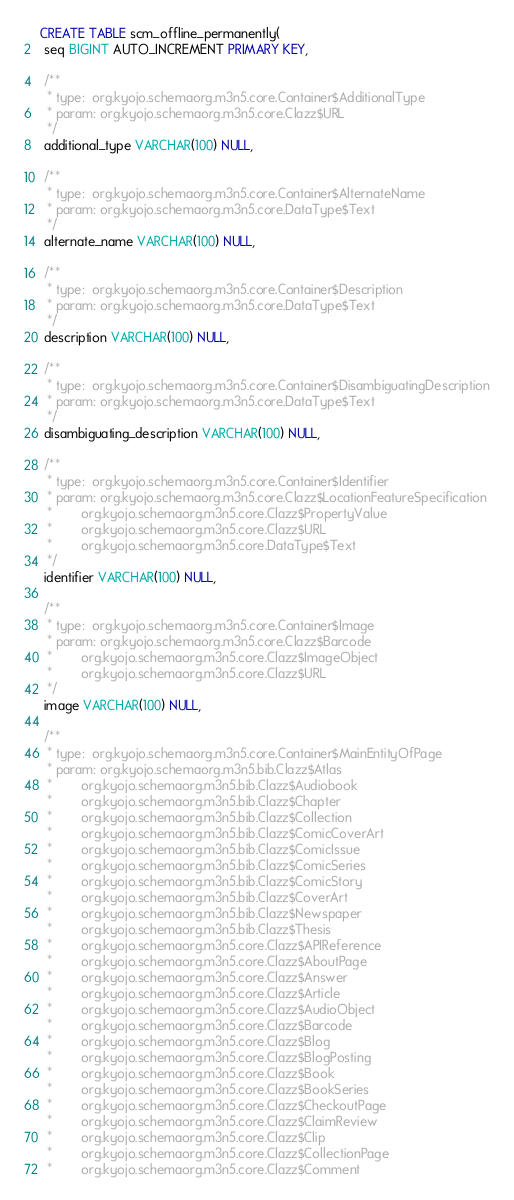Convert code to text. <code><loc_0><loc_0><loc_500><loc_500><_SQL_>CREATE TABLE scm_offline_permanently(
 seq BIGINT AUTO_INCREMENT PRIMARY KEY,

 /**
  * type:  org.kyojo.schemaorg.m3n5.core.Container$AdditionalType
  * param: org.kyojo.schemaorg.m3n5.core.Clazz$URL
  */
 additional_type VARCHAR(100) NULL,

 /**
  * type:  org.kyojo.schemaorg.m3n5.core.Container$AlternateName
  * param: org.kyojo.schemaorg.m3n5.core.DataType$Text
  */
 alternate_name VARCHAR(100) NULL,

 /**
  * type:  org.kyojo.schemaorg.m3n5.core.Container$Description
  * param: org.kyojo.schemaorg.m3n5.core.DataType$Text
  */
 description VARCHAR(100) NULL,

 /**
  * type:  org.kyojo.schemaorg.m3n5.core.Container$DisambiguatingDescription
  * param: org.kyojo.schemaorg.m3n5.core.DataType$Text
  */
 disambiguating_description VARCHAR(100) NULL,

 /**
  * type:  org.kyojo.schemaorg.m3n5.core.Container$Identifier
  * param: org.kyojo.schemaorg.m3n5.core.Clazz$LocationFeatureSpecification
  *        org.kyojo.schemaorg.m3n5.core.Clazz$PropertyValue
  *        org.kyojo.schemaorg.m3n5.core.Clazz$URL
  *        org.kyojo.schemaorg.m3n5.core.DataType$Text
  */
 identifier VARCHAR(100) NULL,

 /**
  * type:  org.kyojo.schemaorg.m3n5.core.Container$Image
  * param: org.kyojo.schemaorg.m3n5.core.Clazz$Barcode
  *        org.kyojo.schemaorg.m3n5.core.Clazz$ImageObject
  *        org.kyojo.schemaorg.m3n5.core.Clazz$URL
  */
 image VARCHAR(100) NULL,

 /**
  * type:  org.kyojo.schemaorg.m3n5.core.Container$MainEntityOfPage
  * param: org.kyojo.schemaorg.m3n5.bib.Clazz$Atlas
  *        org.kyojo.schemaorg.m3n5.bib.Clazz$Audiobook
  *        org.kyojo.schemaorg.m3n5.bib.Clazz$Chapter
  *        org.kyojo.schemaorg.m3n5.bib.Clazz$Collection
  *        org.kyojo.schemaorg.m3n5.bib.Clazz$ComicCoverArt
  *        org.kyojo.schemaorg.m3n5.bib.Clazz$ComicIssue
  *        org.kyojo.schemaorg.m3n5.bib.Clazz$ComicSeries
  *        org.kyojo.schemaorg.m3n5.bib.Clazz$ComicStory
  *        org.kyojo.schemaorg.m3n5.bib.Clazz$CoverArt
  *        org.kyojo.schemaorg.m3n5.bib.Clazz$Newspaper
  *        org.kyojo.schemaorg.m3n5.bib.Clazz$Thesis
  *        org.kyojo.schemaorg.m3n5.core.Clazz$APIReference
  *        org.kyojo.schemaorg.m3n5.core.Clazz$AboutPage
  *        org.kyojo.schemaorg.m3n5.core.Clazz$Answer
  *        org.kyojo.schemaorg.m3n5.core.Clazz$Article
  *        org.kyojo.schemaorg.m3n5.core.Clazz$AudioObject
  *        org.kyojo.schemaorg.m3n5.core.Clazz$Barcode
  *        org.kyojo.schemaorg.m3n5.core.Clazz$Blog
  *        org.kyojo.schemaorg.m3n5.core.Clazz$BlogPosting
  *        org.kyojo.schemaorg.m3n5.core.Clazz$Book
  *        org.kyojo.schemaorg.m3n5.core.Clazz$BookSeries
  *        org.kyojo.schemaorg.m3n5.core.Clazz$CheckoutPage
  *        org.kyojo.schemaorg.m3n5.core.Clazz$ClaimReview
  *        org.kyojo.schemaorg.m3n5.core.Clazz$Clip
  *        org.kyojo.schemaorg.m3n5.core.Clazz$CollectionPage
  *        org.kyojo.schemaorg.m3n5.core.Clazz$Comment</code> 